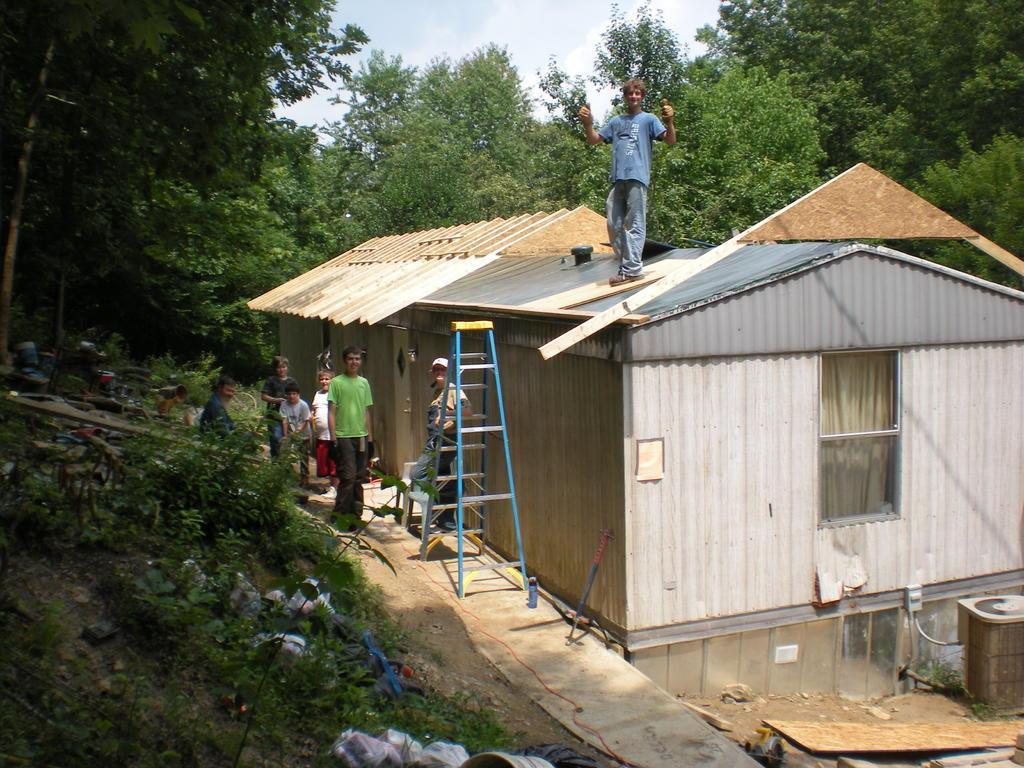Describe this image in one or two sentences. There are houses, a ladder and some people are present in the middle of this image. There is one man standing on a house. We can see trees in the background and the sky is at the top of this image. There are small plants and other objects are present at the bottom of this image. 